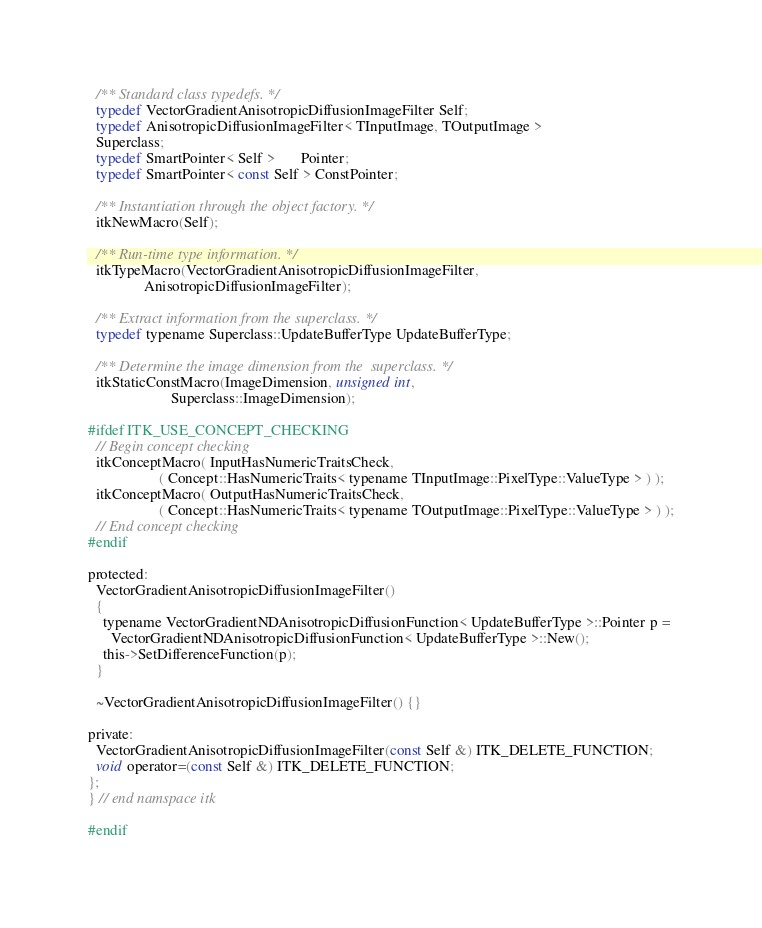Convert code to text. <code><loc_0><loc_0><loc_500><loc_500><_C_>  /** Standard class typedefs. */
  typedef VectorGradientAnisotropicDiffusionImageFilter Self;
  typedef AnisotropicDiffusionImageFilter< TInputImage, TOutputImage >
  Superclass;
  typedef SmartPointer< Self >       Pointer;
  typedef SmartPointer< const Self > ConstPointer;

  /** Instantiation through the object factory. */
  itkNewMacro(Self);

  /** Run-time type information. */
  itkTypeMacro(VectorGradientAnisotropicDiffusionImageFilter,
               AnisotropicDiffusionImageFilter);

  /** Extract information from the superclass. */
  typedef typename Superclass::UpdateBufferType UpdateBufferType;

  /** Determine the image dimension from the  superclass. */
  itkStaticConstMacro(ImageDimension, unsigned int,
                      Superclass::ImageDimension);

#ifdef ITK_USE_CONCEPT_CHECKING
  // Begin concept checking
  itkConceptMacro( InputHasNumericTraitsCheck,
                   ( Concept::HasNumericTraits< typename TInputImage::PixelType::ValueType > ) );
  itkConceptMacro( OutputHasNumericTraitsCheck,
                   ( Concept::HasNumericTraits< typename TOutputImage::PixelType::ValueType > ) );
  // End concept checking
#endif

protected:
  VectorGradientAnisotropicDiffusionImageFilter()
  {
    typename VectorGradientNDAnisotropicDiffusionFunction< UpdateBufferType >::Pointer p =
      VectorGradientNDAnisotropicDiffusionFunction< UpdateBufferType >::New();
    this->SetDifferenceFunction(p);
  }

  ~VectorGradientAnisotropicDiffusionImageFilter() {}

private:
  VectorGradientAnisotropicDiffusionImageFilter(const Self &) ITK_DELETE_FUNCTION;
  void operator=(const Self &) ITK_DELETE_FUNCTION;
};
} // end namspace itk

#endif
</code> 